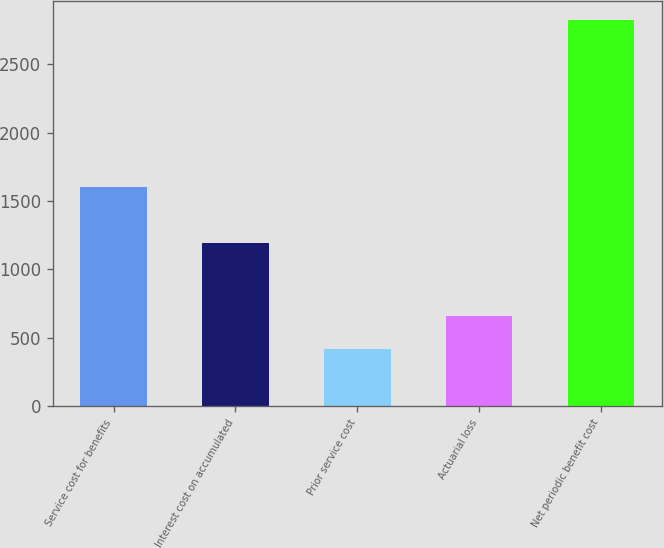Convert chart to OTSL. <chart><loc_0><loc_0><loc_500><loc_500><bar_chart><fcel>Service cost for benefits<fcel>Interest cost on accumulated<fcel>Prior service cost<fcel>Actuarial loss<fcel>Net periodic benefit cost<nl><fcel>1599<fcel>1189<fcel>416<fcel>656.5<fcel>2821<nl></chart> 